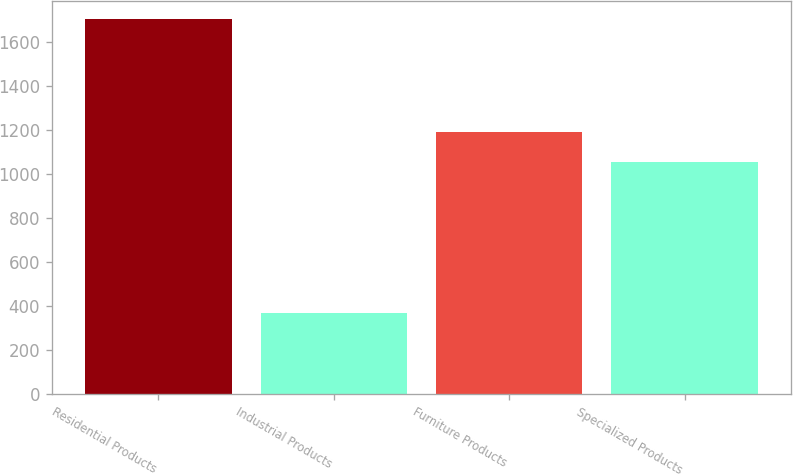<chart> <loc_0><loc_0><loc_500><loc_500><bar_chart><fcel>Residential Products<fcel>Industrial Products<fcel>Furniture Products<fcel>Specialized Products<nl><fcel>1703.7<fcel>367.4<fcel>1189.93<fcel>1056.3<nl></chart> 